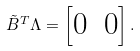<formula> <loc_0><loc_0><loc_500><loc_500>\tilde { B } ^ { T } \Lambda = \left [ \begin{matrix} 0 & 0 \end{matrix} \right ] .</formula> 